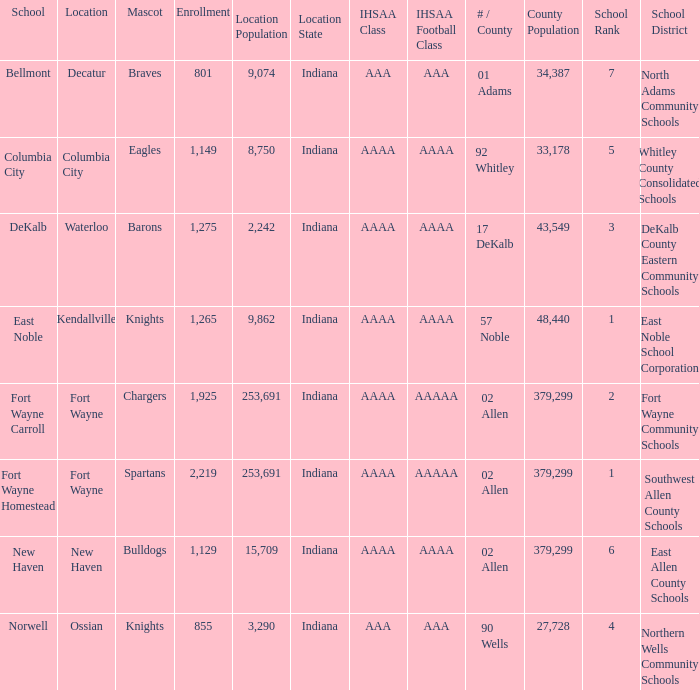Parse the table in full. {'header': ['School', 'Location', 'Mascot', 'Enrollment', 'Location Population', 'Location State', 'IHSAA Class', 'IHSAA Football Class', '# / County', 'County Population', 'School Rank', 'School District'], 'rows': [['Bellmont', 'Decatur', 'Braves', '801', '9,074', 'Indiana', 'AAA', 'AAA', '01 Adams', '34,387', '7', 'North Adams Community Schools'], ['Columbia City', 'Columbia City', 'Eagles', '1,149', '8,750', 'Indiana', 'AAAA', 'AAAA', '92 Whitley', '33,178', '5', 'Whitley County Consolidated Schools'], ['DeKalb', 'Waterloo', 'Barons', '1,275', '2,242', 'Indiana', 'AAAA', 'AAAA', '17 DeKalb', '43,549', '3', 'DeKalb County Eastern Community Schools'], ['East Noble', 'Kendallville', 'Knights', '1,265', '9,862', 'Indiana', 'AAAA', 'AAAA', '57 Noble', '48,440', '1', 'East Noble School Corporation'], ['Fort Wayne Carroll', 'Fort Wayne', 'Chargers', '1,925', '253,691', 'Indiana', 'AAAA', 'AAAAA', '02 Allen', '379,299', '2', 'Fort Wayne Community Schools'], ['Fort Wayne Homestead', 'Fort Wayne', 'Spartans', '2,219', '253,691', 'Indiana', 'AAAA', 'AAAAA', '02 Allen', '379,299', '1', 'Southwest Allen County Schools'], ['New Haven', 'New Haven', 'Bulldogs', '1,129', '15,709', 'Indiana', 'AAAA', 'AAAA', '02 Allen', '379,299', '6', 'East Allen County Schools'], ['Norwell', 'Ossian', 'Knights', '855', '3,290', 'Indiana', 'AAA', 'AAA', '90 Wells', '27,728', '4', 'Northern Wells Community Schools']]} What's the enrollment for Kendallville? 1265.0. 